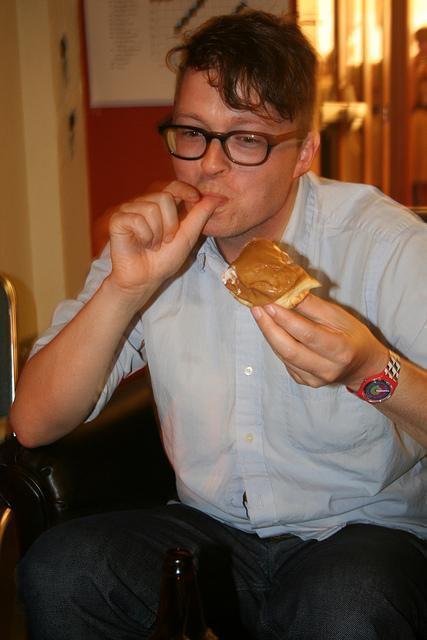How many zebras have their back turned to the camera?
Give a very brief answer. 0. 